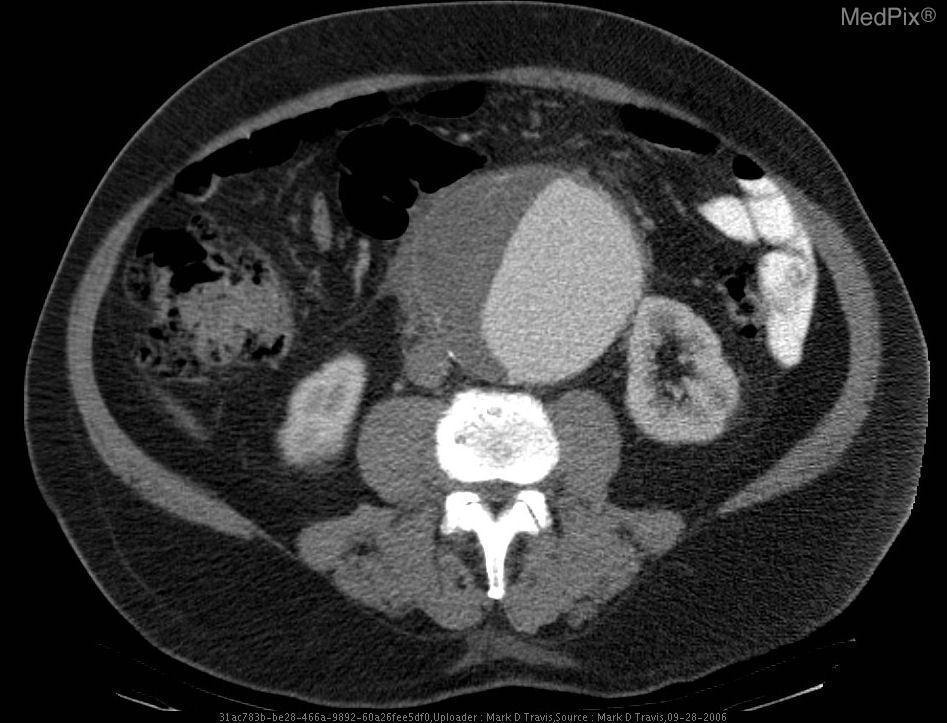Can the kidneys be visualized in this ct scan?
Quick response, please. Yes. Is this ct scan enhanced by iv contrast?
Write a very short answer. Yes. Is the width of the abdominal aorta within normal limits?
Short answer required. No. 